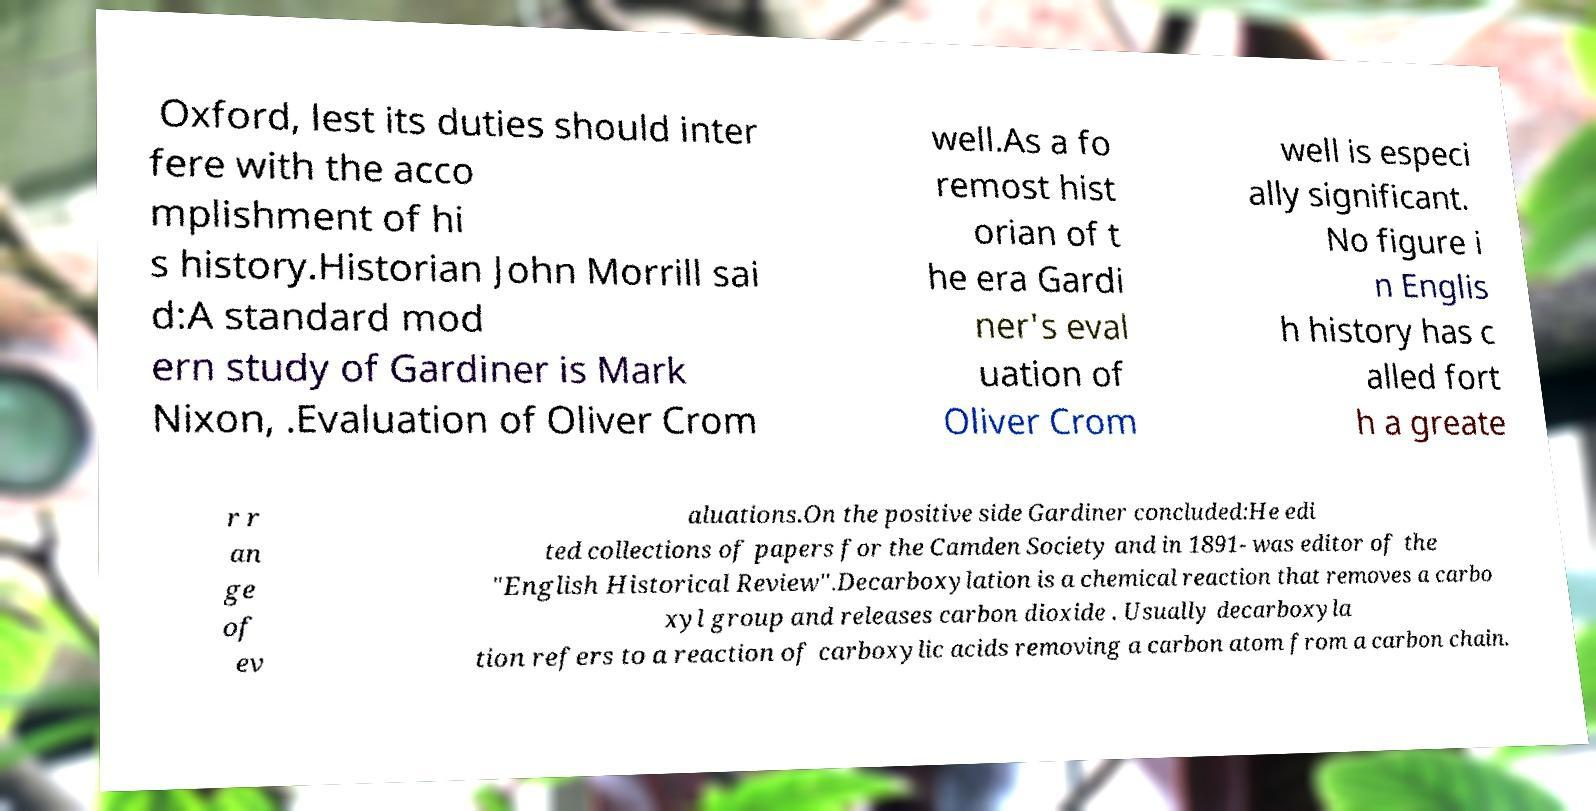I need the written content from this picture converted into text. Can you do that? Oxford, lest its duties should inter fere with the acco mplishment of hi s history.Historian John Morrill sai d:A standard mod ern study of Gardiner is Mark Nixon, .Evaluation of Oliver Crom well.As a fo remost hist orian of t he era Gardi ner's eval uation of Oliver Crom well is especi ally significant. No figure i n Englis h history has c alled fort h a greate r r an ge of ev aluations.On the positive side Gardiner concluded:He edi ted collections of papers for the Camden Society and in 1891- was editor of the "English Historical Review".Decarboxylation is a chemical reaction that removes a carbo xyl group and releases carbon dioxide . Usually decarboxyla tion refers to a reaction of carboxylic acids removing a carbon atom from a carbon chain. 